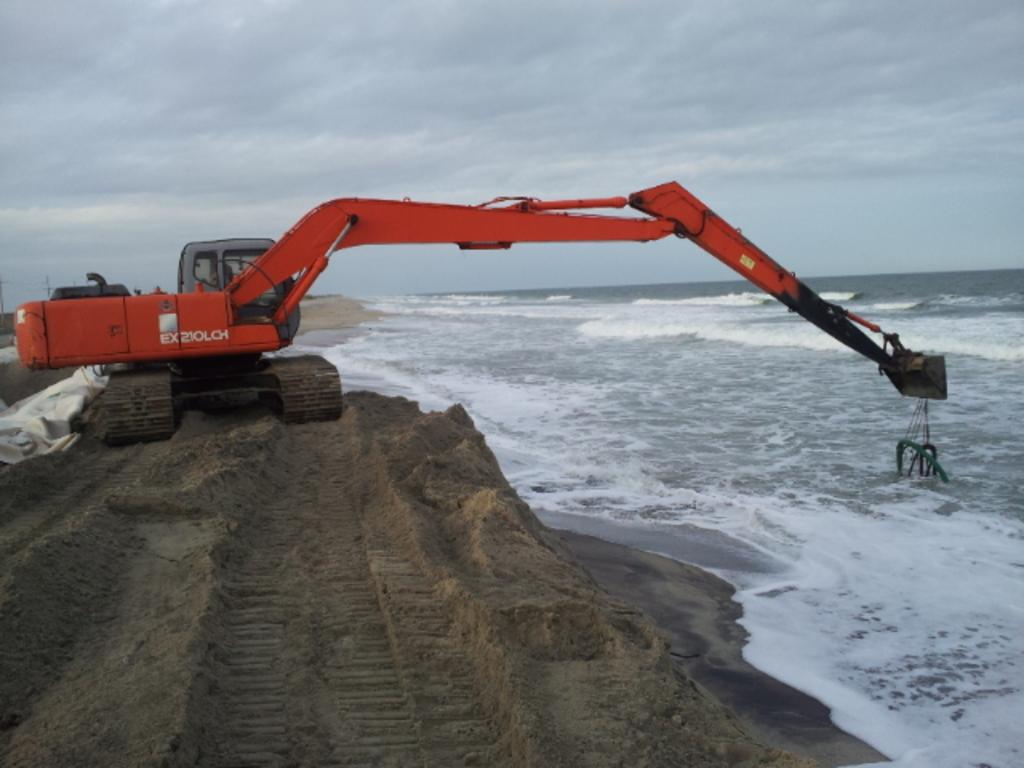What is the main subject of the image? There is a vehicle in the image. Where is the vehicle located? The vehicle is on the sand. What else can be seen in the image besides the vehicle? There is water visible in the image. What is visible in the background of the image? The sky is visible in the background of the image. What type of art can be seen hanging on the wall in the image? There is no art or wall present in the image; it features a vehicle on the sand with water and the sky visible in the background. 